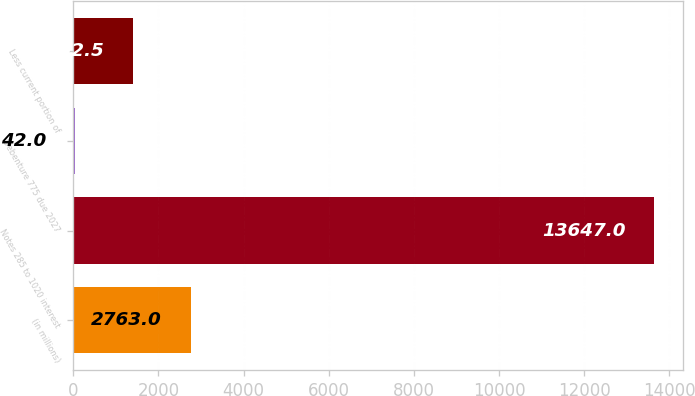Convert chart to OTSL. <chart><loc_0><loc_0><loc_500><loc_500><bar_chart><fcel>(in millions)<fcel>Notes 285 to 1020 interest<fcel>Debenture 775 due 2027<fcel>Less current portion of<nl><fcel>2763<fcel>13647<fcel>42<fcel>1402.5<nl></chart> 